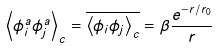Convert formula to latex. <formula><loc_0><loc_0><loc_500><loc_500>\left \langle \phi _ { i } ^ { a } \phi _ { j } ^ { a } \right \rangle _ { c } = \overline { \left \langle \phi _ { i } \phi _ { j } \right \rangle _ { c } } = \beta \frac { e ^ { - r / r _ { 0 } } } { r }</formula> 